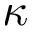Convert formula to latex. <formula><loc_0><loc_0><loc_500><loc_500>\kappa</formula> 